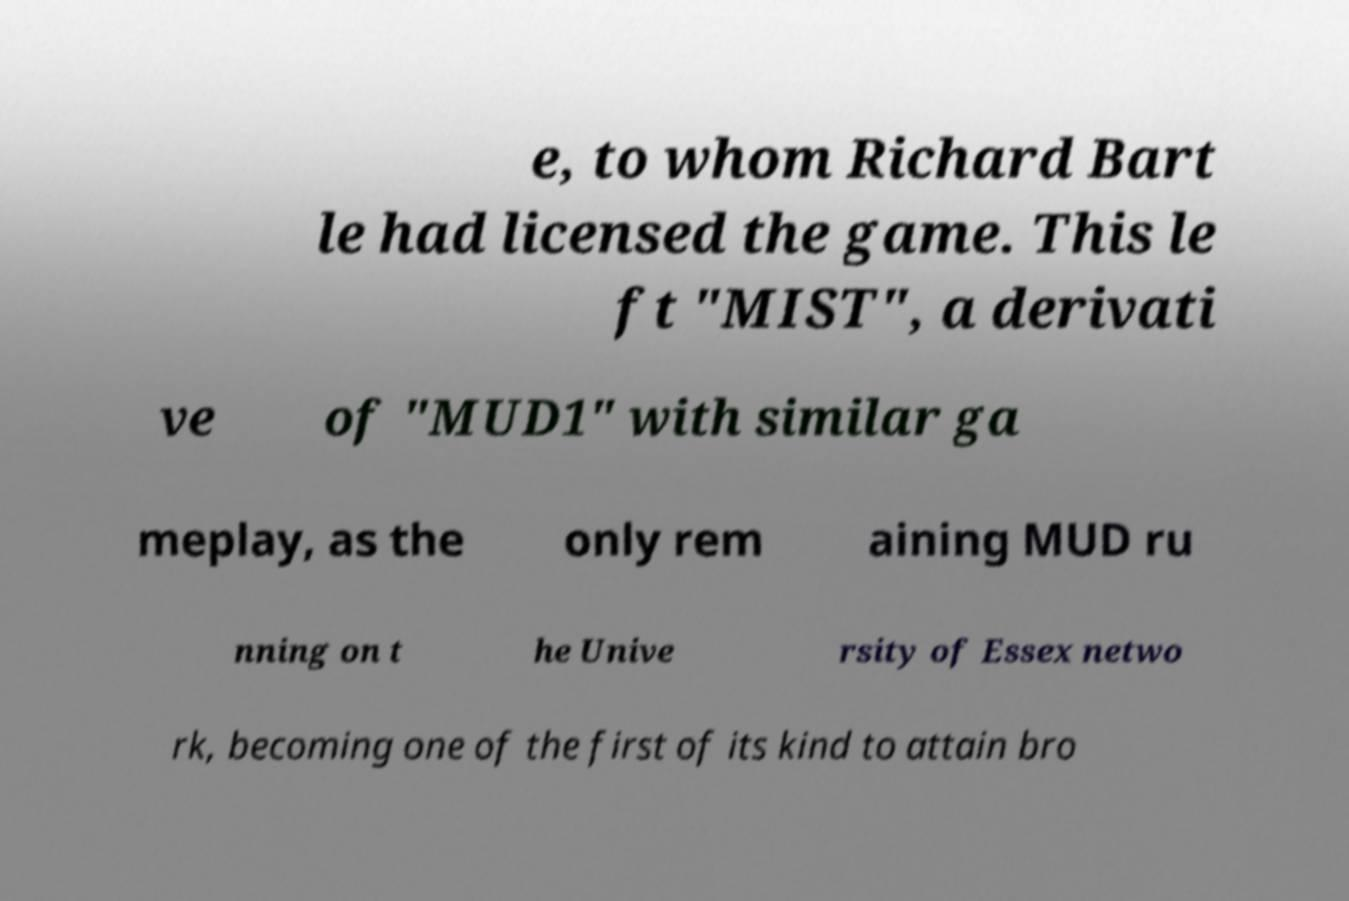Could you assist in decoding the text presented in this image and type it out clearly? e, to whom Richard Bart le had licensed the game. This le ft "MIST", a derivati ve of "MUD1" with similar ga meplay, as the only rem aining MUD ru nning on t he Unive rsity of Essex netwo rk, becoming one of the first of its kind to attain bro 